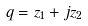<formula> <loc_0><loc_0><loc_500><loc_500>q = z _ { 1 } + j z _ { 2 }</formula> 